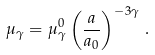Convert formula to latex. <formula><loc_0><loc_0><loc_500><loc_500>\mu _ { \gamma } = \mu _ { \gamma } ^ { 0 } \left ( \frac { a } { a _ { 0 } } \right ) ^ { - 3 \gamma } \, .</formula> 